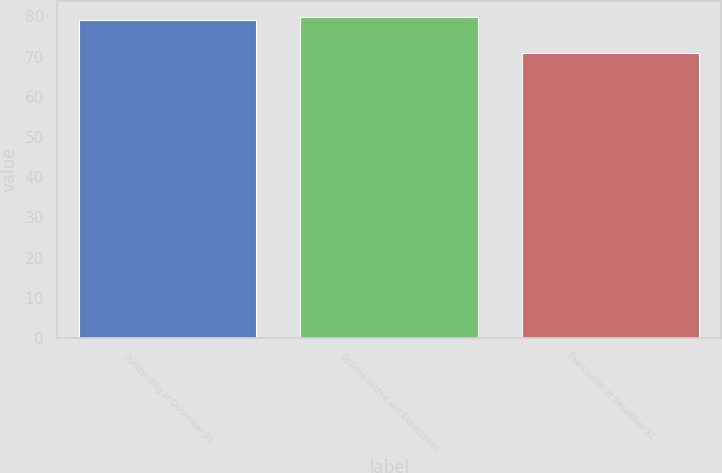Convert chart to OTSL. <chart><loc_0><loc_0><loc_500><loc_500><bar_chart><fcel>Outstanding at December 31<fcel>Options Vested and Expected to<fcel>Exercisable at December 31<nl><fcel>79<fcel>79.8<fcel>71<nl></chart> 